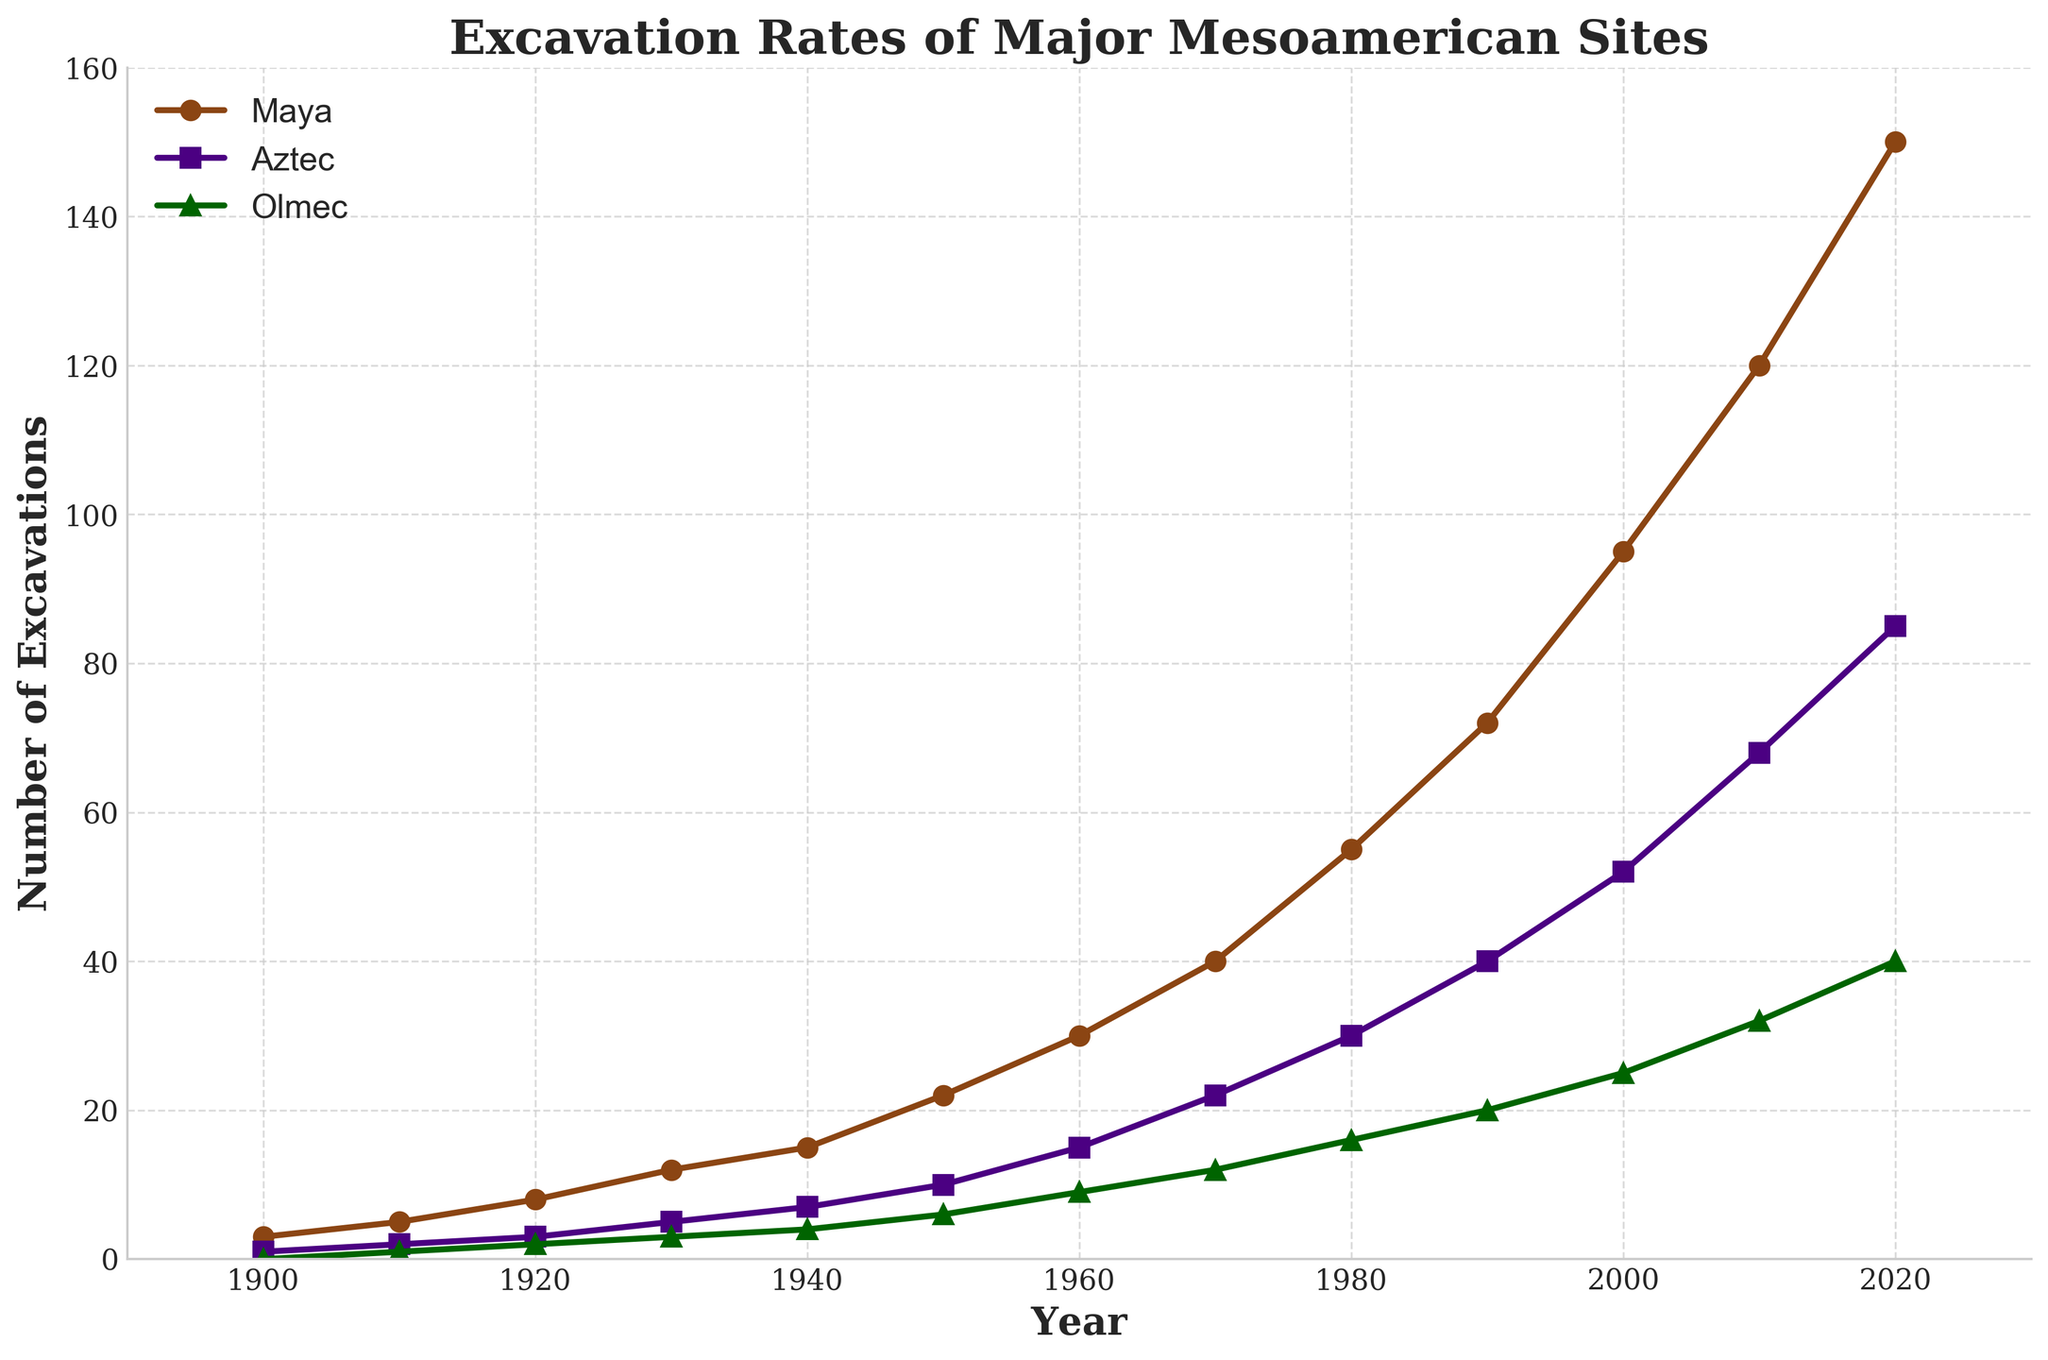What is the difference in the number of excavations between the Maya and Aztec cultures in the year 2010? To find the difference, subtract the number of Aztec excavations from the number of Maya excavations in 2010. Maya: 120, Aztec: 68. Difference: 120 - 68 = 52
Answer: 52 Which culture had the highest number of excavations in 1920? Compare the excavation counts for the Maya, Aztec, and Olmec in 1920. Maya: 8, Aztec: 3, Olmec: 2. The Maya had the highest number.
Answer: Maya Between which two decades did the number of Maya excavations see the largest increase? Calculate the increase for each decade: 
1910-1920: 8 - 5 = 3,
1920-1930: 12 - 8 = 4,
1930-1940: 15 - 12 = 3,
1940-1950: 22 - 15 = 7,
1950-1960: 30 - 22 = 8,
1960-1970: 40 - 30 = 10,
1970-1980: 55 - 40 = 15,
1980-1990: 72 - 55 = 17,
1990-2000: 95 - 72 = 23,
2000-2010: 120 - 95 = 25,
2010-2020: 150 - 120 = 30. 
The largest increase was between 2010 and 2020.
Answer: 2010-2020 What is the average number of Olmec excavations over the recorded years? Add up the number of Olmec excavations for each recorded year and divide by the number of years: (0 + 1 + 2 + 3 + 4 + 6 + 9 + 12 + 16 + 20 + 25 + 32 + 40) / 13 = 170 / 13 ≈ 13.08
Answer: 13.08 How many cultures had fewer than 10 excavations in the year 1930? Looking at the numbers: Maya: 12, Aztec: 5, Olmec: 3. Aztec and Olmec both had fewer than 10 excavations.
Answer: 2 Which year saw the most balanced number of excavations across all three cultures? Calculate the years where differences between cultures are smallest:
1910: Maya: 4, Aztec: 3, Olmec: 1,
1920: Maya: 6, Aztec: 5, Olmec: 1,
1930: Maya: 9, Aztec: 9, Olmec: 6,
1970: Maya: 10, Aztec: 7, Olmec: 3,
1980: Maya: 17, Aztec: 16, Olmec: 14,
2020: Maya: 30, Aztec: 25, Olmec: 20.
1930 shows the smallest maximum difference of 6 between cultures.
Answer: 1930 